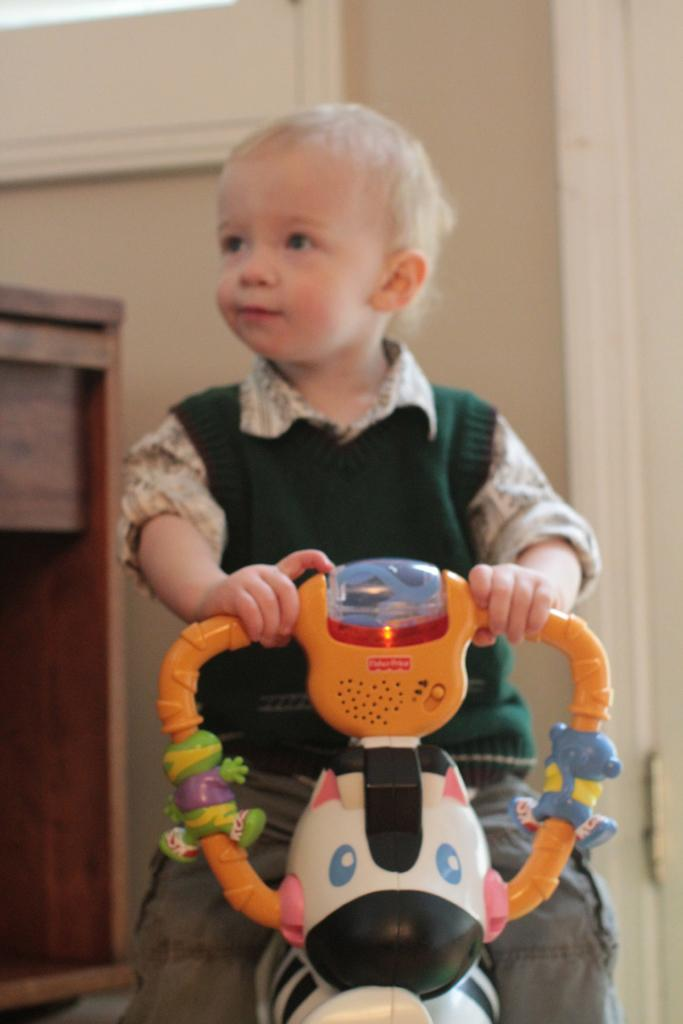What is the main subject of the image? The main subject of the image is a kid. What is the kid doing in the image? The kid is sitting on a toy vehicle. What can be seen in the background of the image? There is a wooden cupboard and a wall in the background. What type of silverware is the kid using to play with the boat in the image? There is no silverware or boat present in the image. How many beans are visible on the wall in the image? There are no beans visible on the wall in the image. 